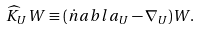Convert formula to latex. <formula><loc_0><loc_0><loc_500><loc_500>\widehat { K } _ { U } { W } \equiv ( \dot { n } a b l a _ { U } - \nabla _ { U } ) { W } .</formula> 